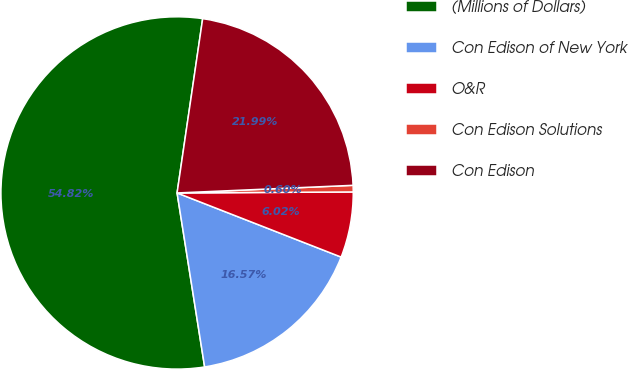<chart> <loc_0><loc_0><loc_500><loc_500><pie_chart><fcel>(Millions of Dollars)<fcel>Con Edison of New York<fcel>O&R<fcel>Con Edison Solutions<fcel>Con Edison<nl><fcel>54.82%<fcel>16.57%<fcel>6.02%<fcel>0.6%<fcel>21.99%<nl></chart> 